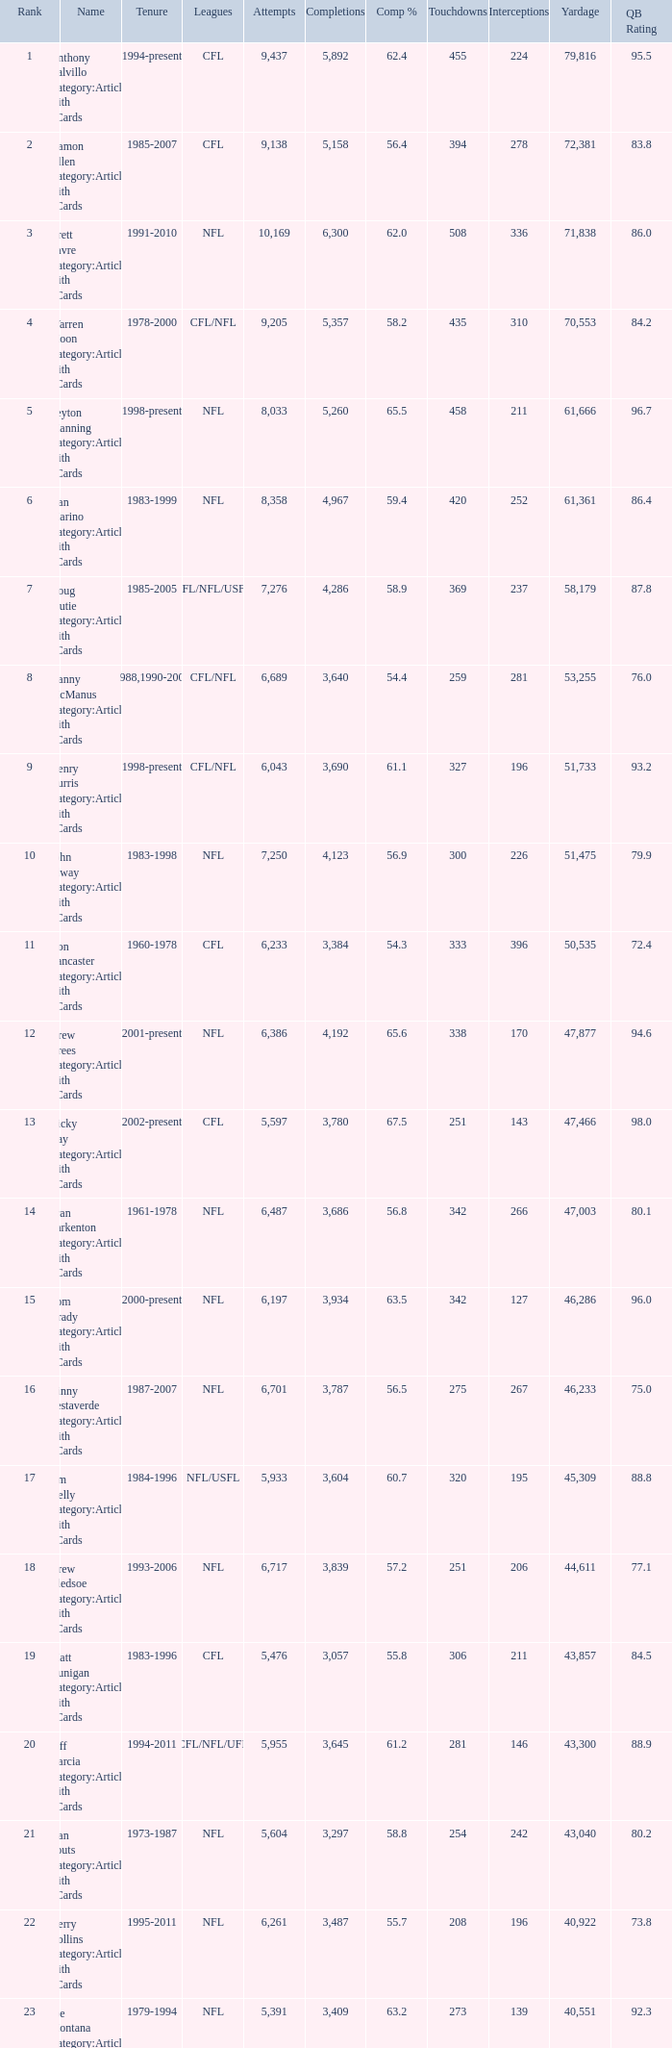What is the count of interceptions with fewer than 3,487 completions, over 40,551 yards, and a completion percentage of 5 211.0. 